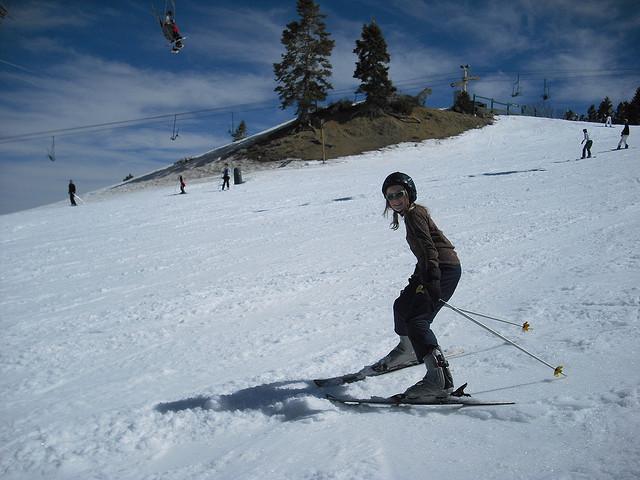How many people do you see?
Give a very brief answer. 8. How many people are in the photo?
Give a very brief answer. 1. How many benches are there?
Give a very brief answer. 0. 